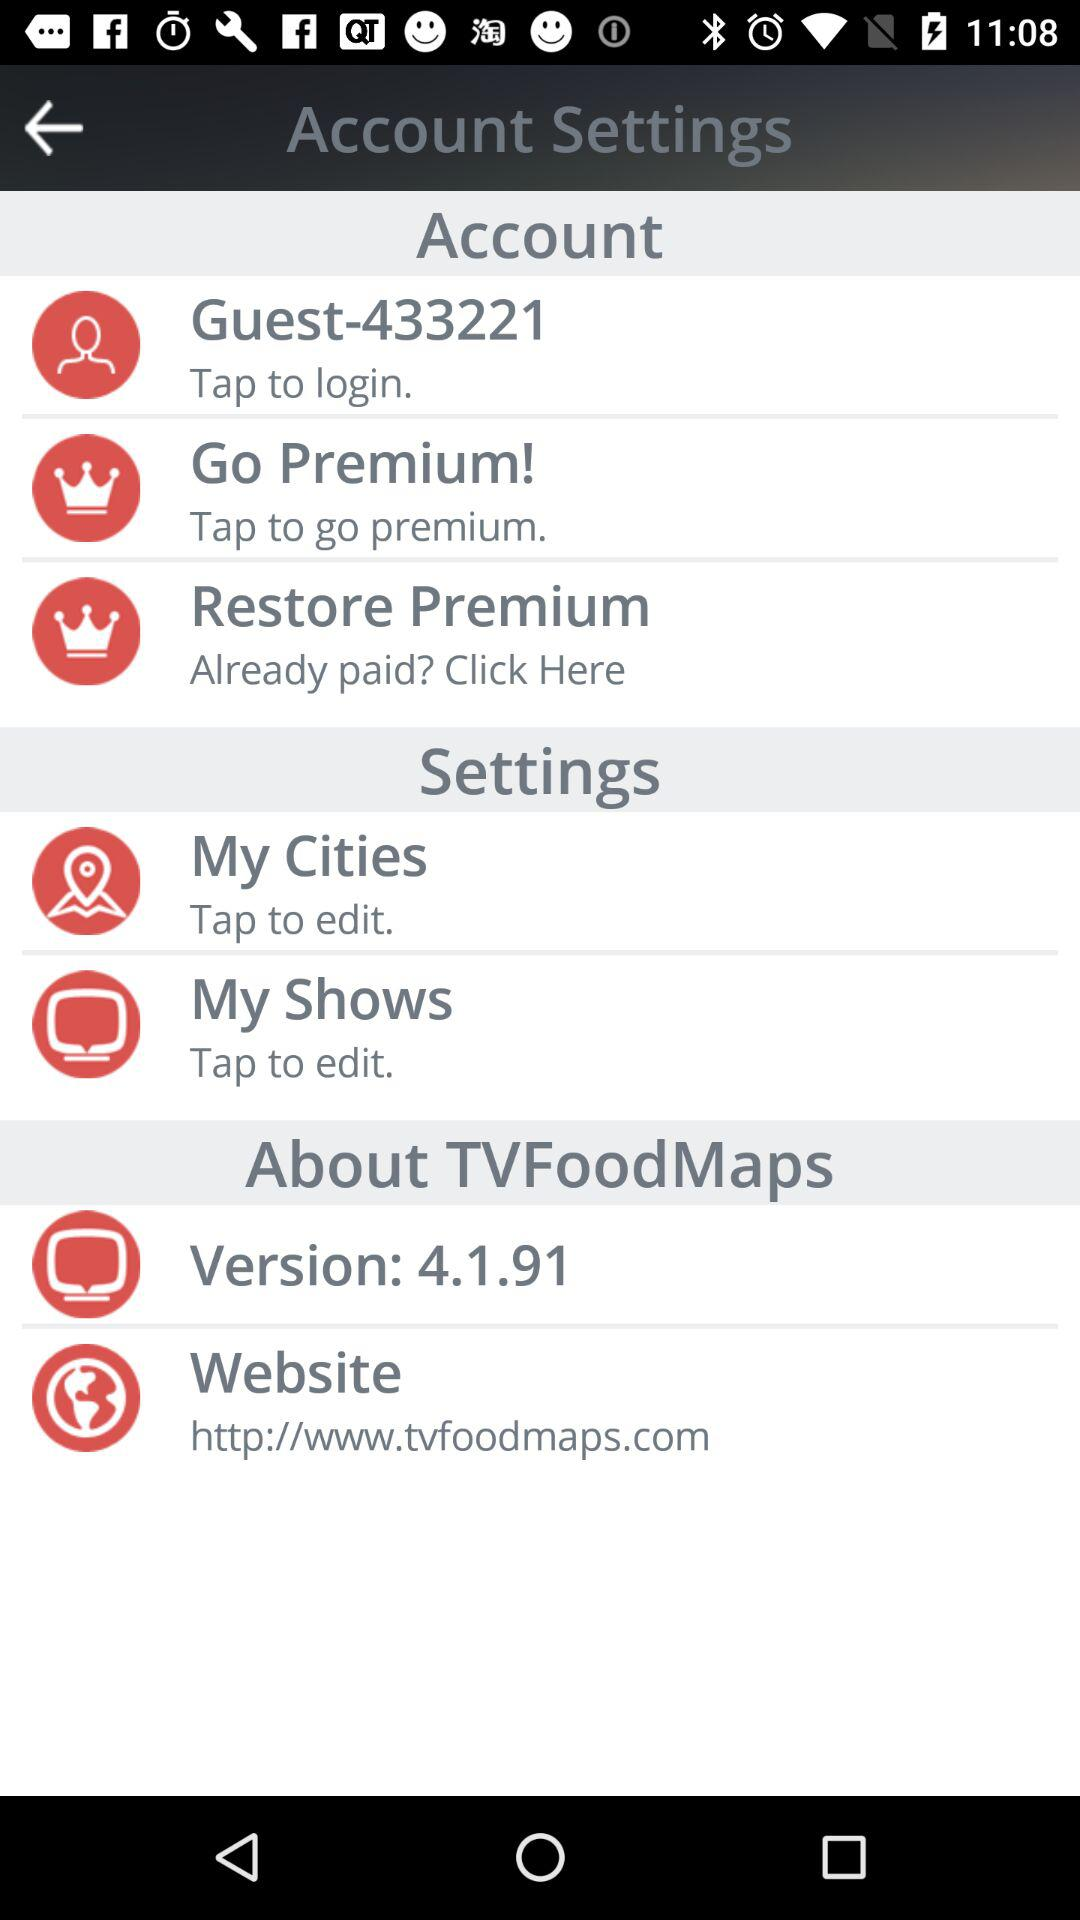What is the guest number? The guest number is 433221. 